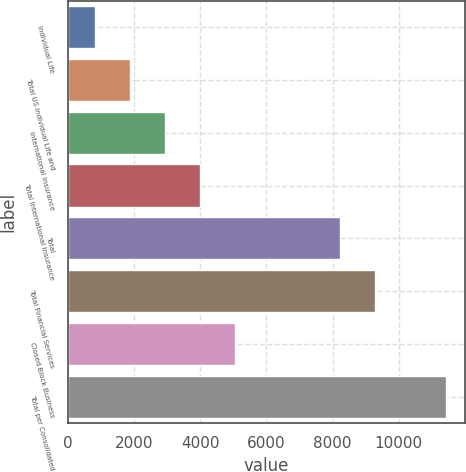<chart> <loc_0><loc_0><loc_500><loc_500><bar_chart><fcel>Individual Life<fcel>Total US Individual Life and<fcel>International Insurance<fcel>Total International Insurance<fcel>Total<fcel>Total Financial Services<fcel>Closed Block Business<fcel>Total per Consolidated<nl><fcel>809<fcel>1870.2<fcel>2931.4<fcel>3992.6<fcel>8231<fcel>9292.2<fcel>5053.8<fcel>11421<nl></chart> 